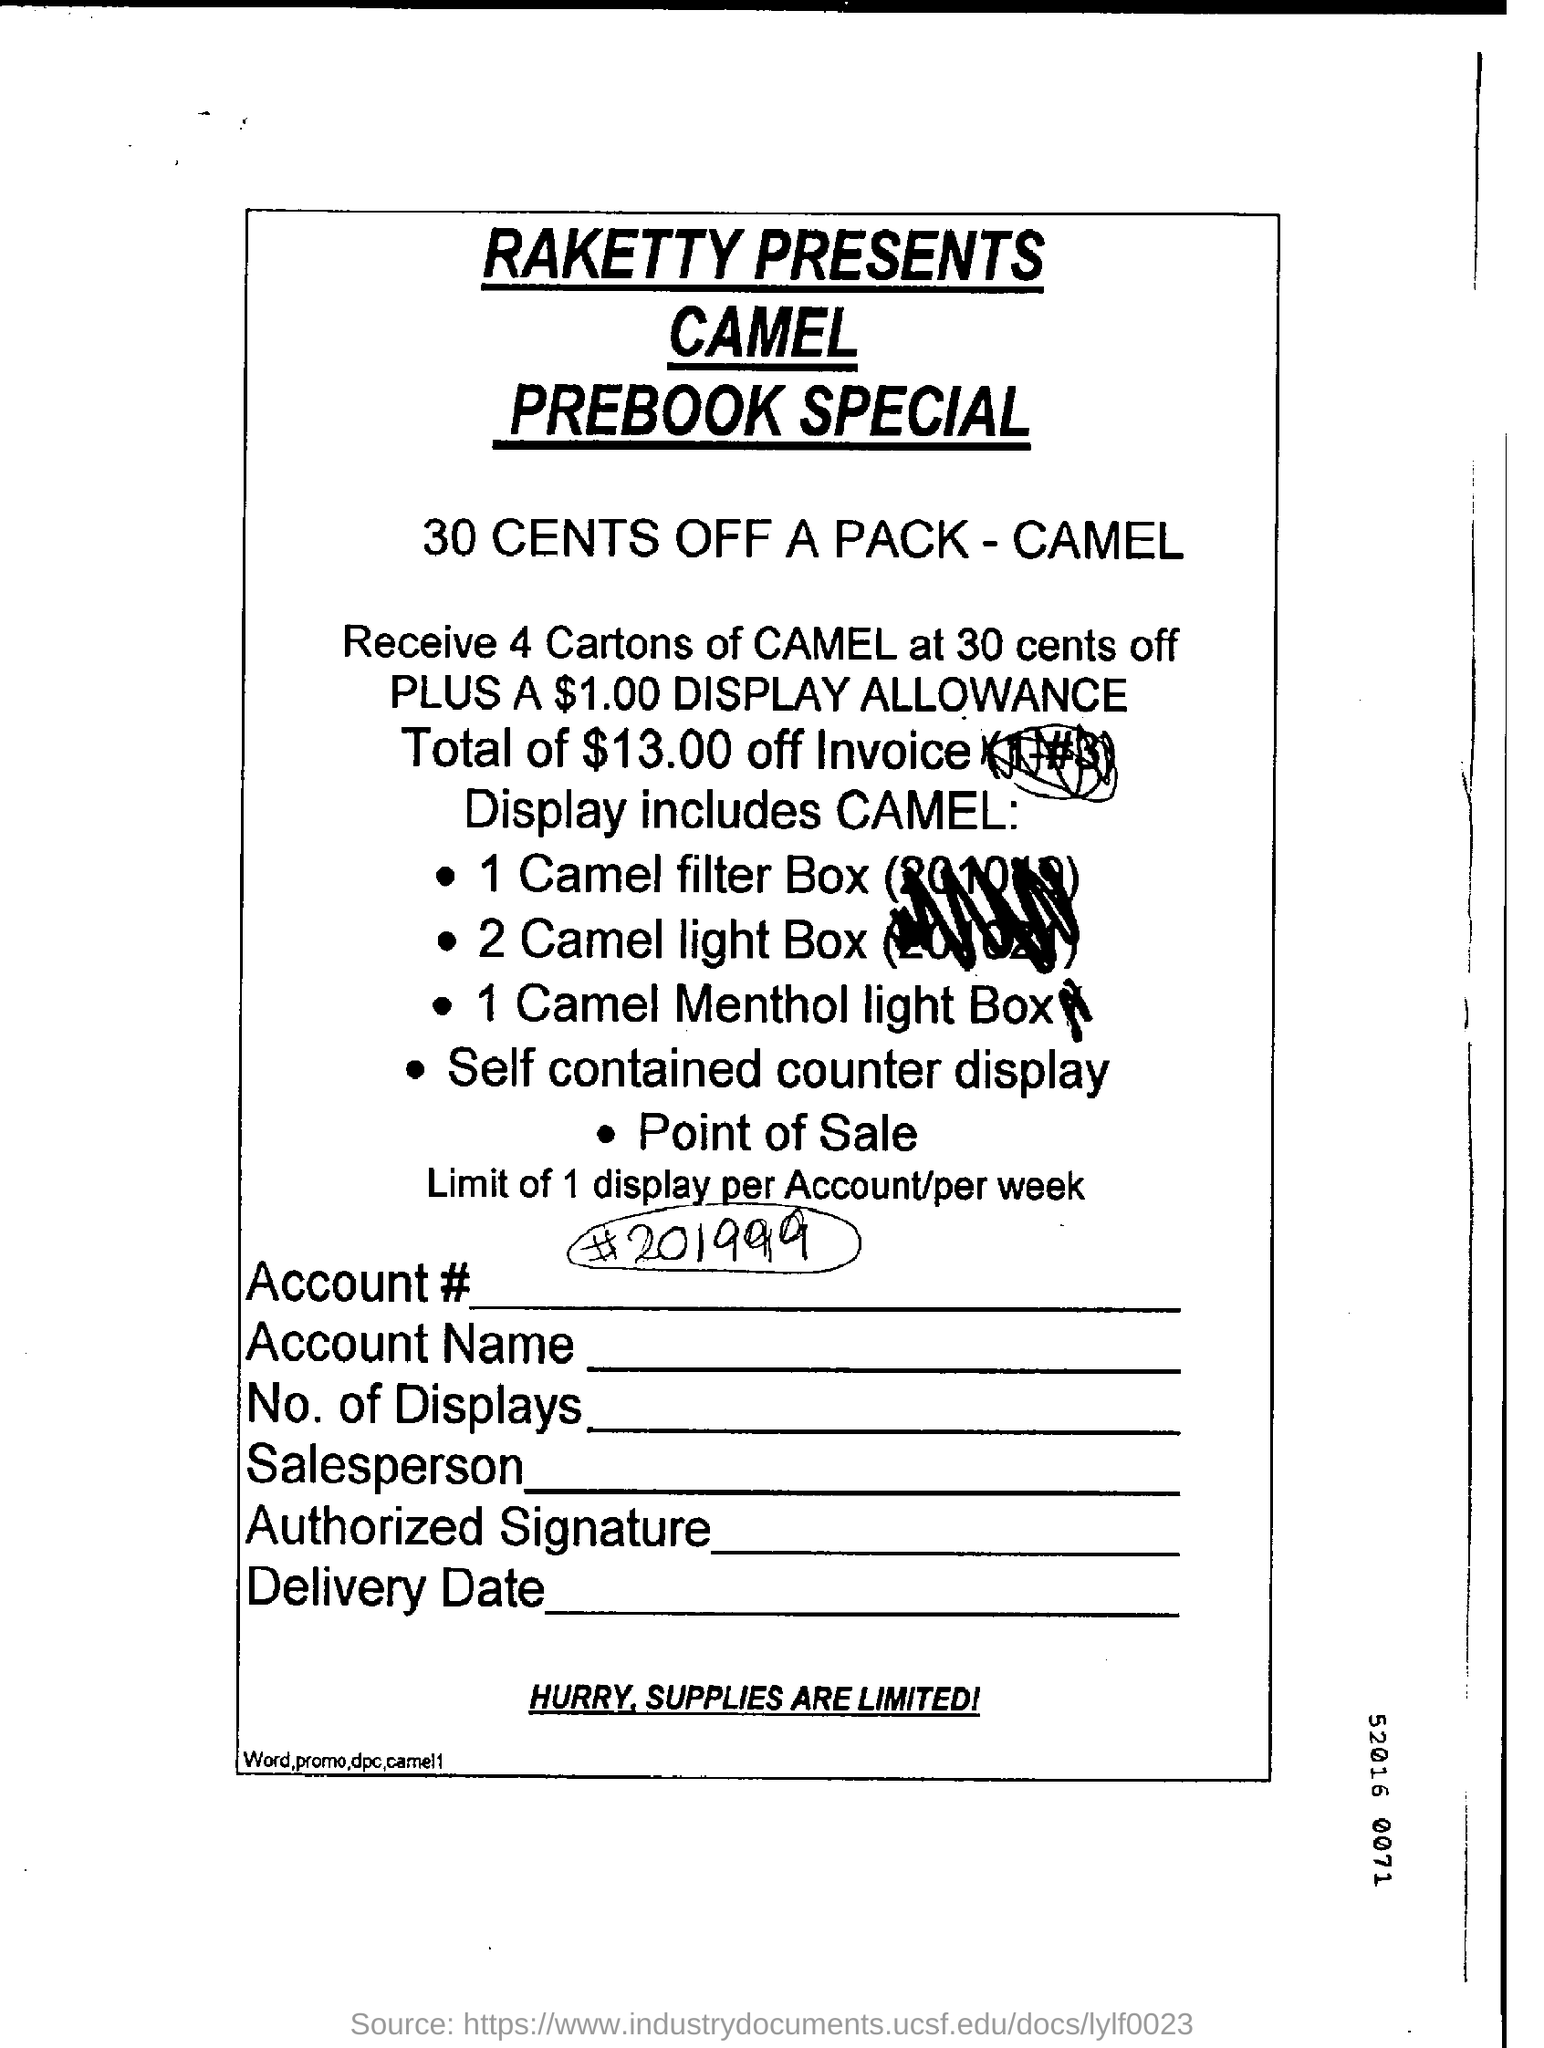What is the headline?
Offer a terse response. Raketty presents camel prebook special. What amount offered as display allowance?
Ensure brevity in your answer.  $ 1.00. 